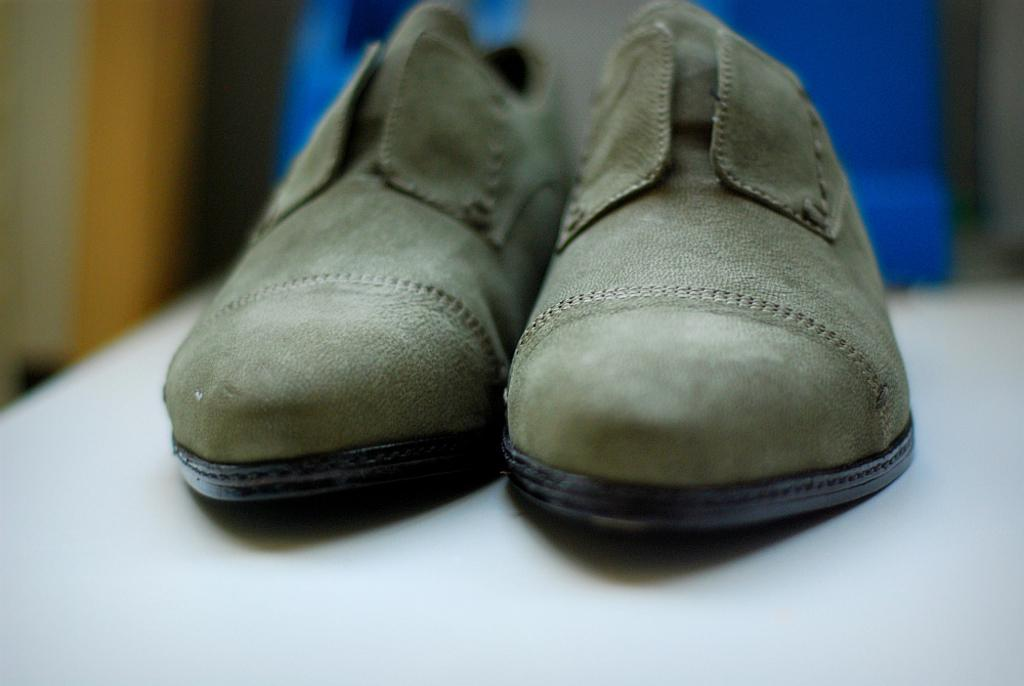What color are the shoes in the image? The shoes in the image are green. Where are the shoes placed? The shoes are placed on a white table. Can you describe the background of the image? There is a blurred blue object in the background of the image. What type of rake is being used by the person in the image? There is no person or rake present in the image; it only features green shoes on a white table with a blurred blue object in the background. 